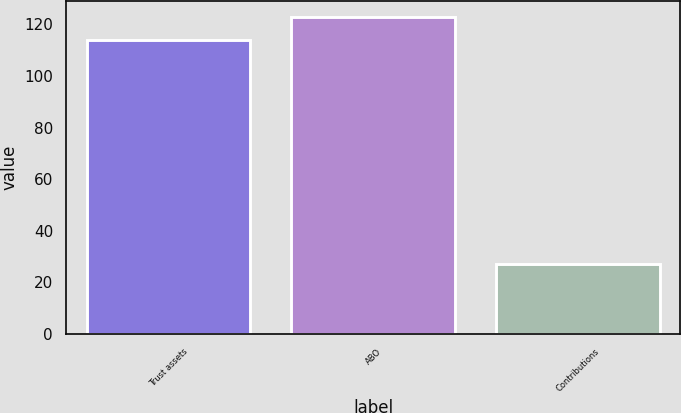Convert chart to OTSL. <chart><loc_0><loc_0><loc_500><loc_500><bar_chart><fcel>Trust assets<fcel>ABO<fcel>Contributions<nl><fcel>114<fcel>123<fcel>27<nl></chart> 